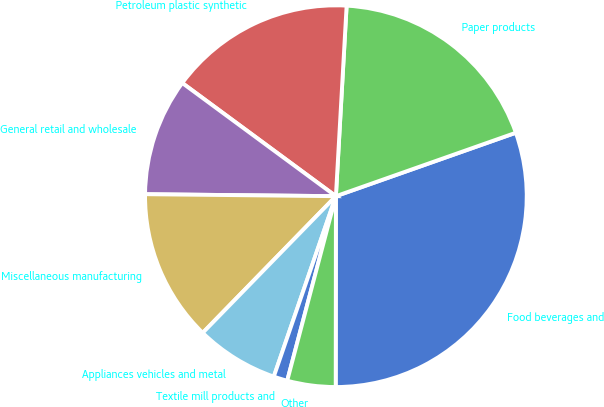<chart> <loc_0><loc_0><loc_500><loc_500><pie_chart><fcel>Food beverages and<fcel>Paper products<fcel>Petroleum plastic synthetic<fcel>General retail and wholesale<fcel>Miscellaneous manufacturing<fcel>Appliances vehicles and metal<fcel>Textile mill products and<fcel>Other<nl><fcel>30.41%<fcel>18.71%<fcel>15.79%<fcel>9.94%<fcel>12.87%<fcel>7.02%<fcel>1.17%<fcel>4.09%<nl></chart> 